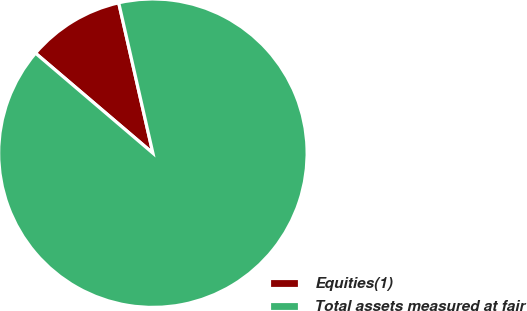Convert chart. <chart><loc_0><loc_0><loc_500><loc_500><pie_chart><fcel>Equities(1)<fcel>Total assets measured at fair<nl><fcel>10.21%<fcel>89.79%<nl></chart> 